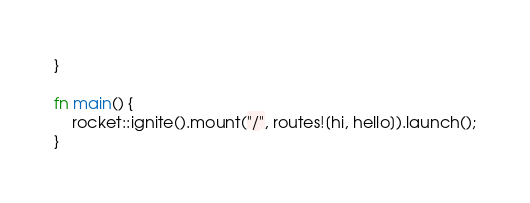<code> <loc_0><loc_0><loc_500><loc_500><_Rust_>}

fn main() {
    rocket::ignite().mount("/", routes![hi, hello]).launch();
}
</code> 